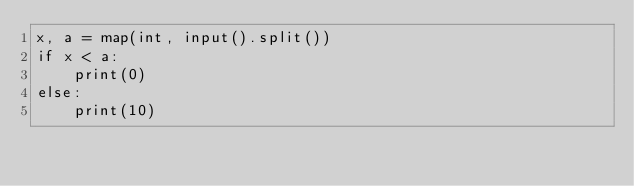<code> <loc_0><loc_0><loc_500><loc_500><_Python_>x, a = map(int, input().split())
if x < a:
    print(0)
else:
    print(10)</code> 